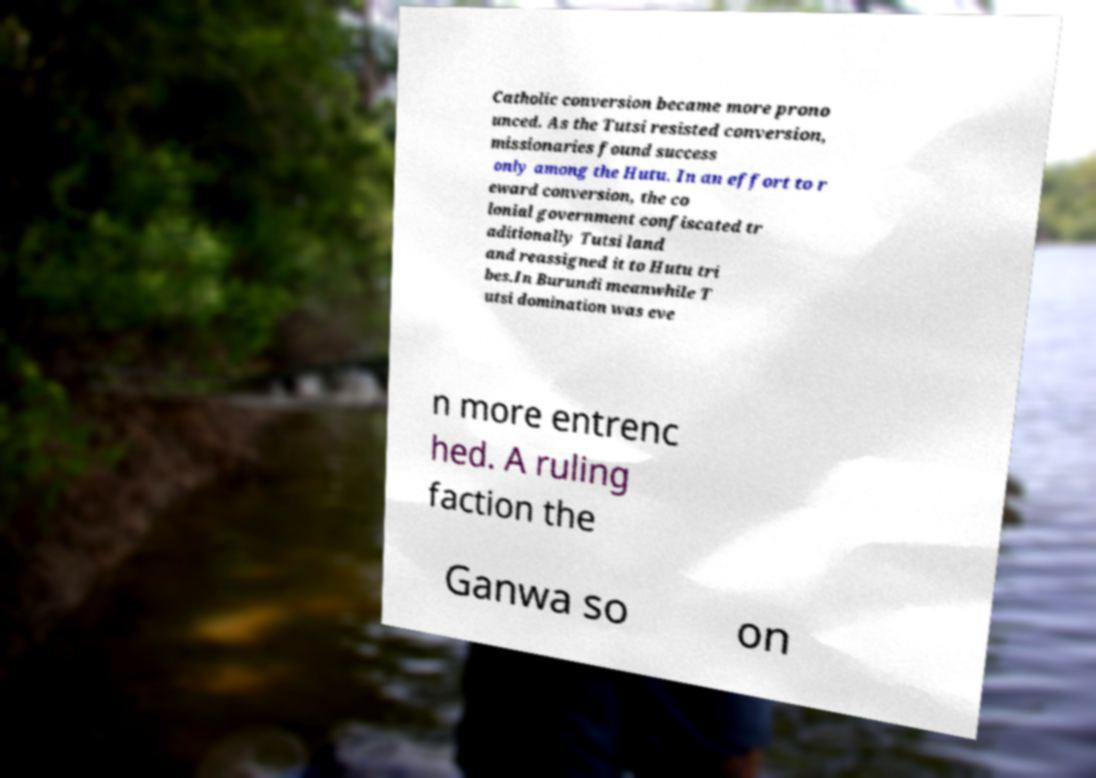I need the written content from this picture converted into text. Can you do that? Catholic conversion became more prono unced. As the Tutsi resisted conversion, missionaries found success only among the Hutu. In an effort to r eward conversion, the co lonial government confiscated tr aditionally Tutsi land and reassigned it to Hutu tri bes.In Burundi meanwhile T utsi domination was eve n more entrenc hed. A ruling faction the Ganwa so on 